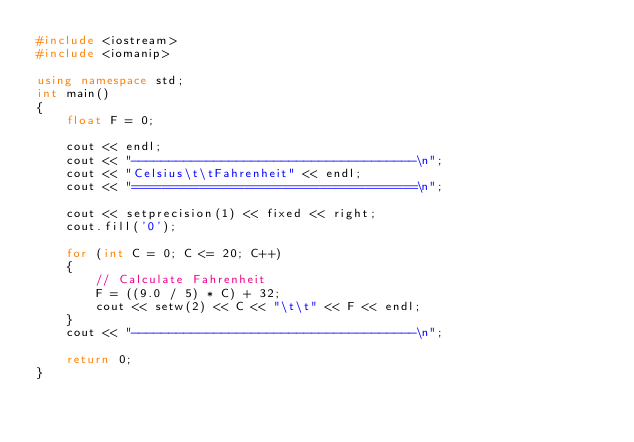<code> <loc_0><loc_0><loc_500><loc_500><_C++_>#include <iostream>
#include <iomanip>

using namespace std;
int main()
{
    float F = 0;

    cout << endl;
    cout << "--------------------------------------\n";
    cout << "Celsius\t\tFahrenheit" << endl;
    cout << "======================================\n";

    cout << setprecision(1) << fixed << right;
    cout.fill('0');

    for (int C = 0; C <= 20; C++)
    {
        // Calculate Fahrenheit
        F = ((9.0 / 5) * C) + 32;
        cout << setw(2) << C << "\t\t" << F << endl;
    }
    cout << "--------------------------------------\n";

    return 0;
}</code> 